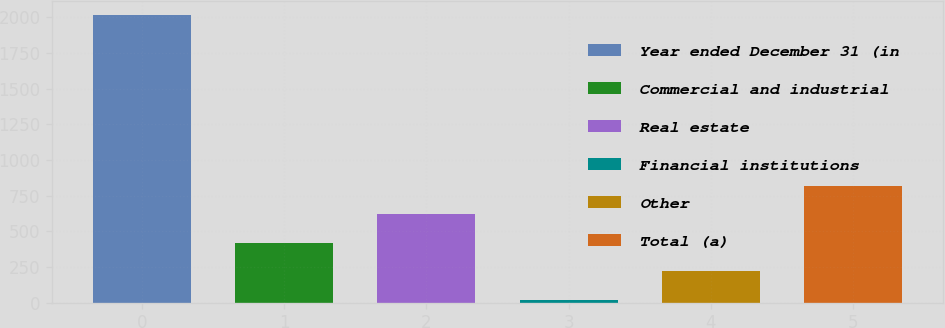Convert chart. <chart><loc_0><loc_0><loc_500><loc_500><bar_chart><fcel>Year ended December 31 (in<fcel>Commercial and industrial<fcel>Real estate<fcel>Financial institutions<fcel>Other<fcel>Total (a)<nl><fcel>2014<fcel>418.8<fcel>618.2<fcel>20<fcel>219.4<fcel>817.6<nl></chart> 